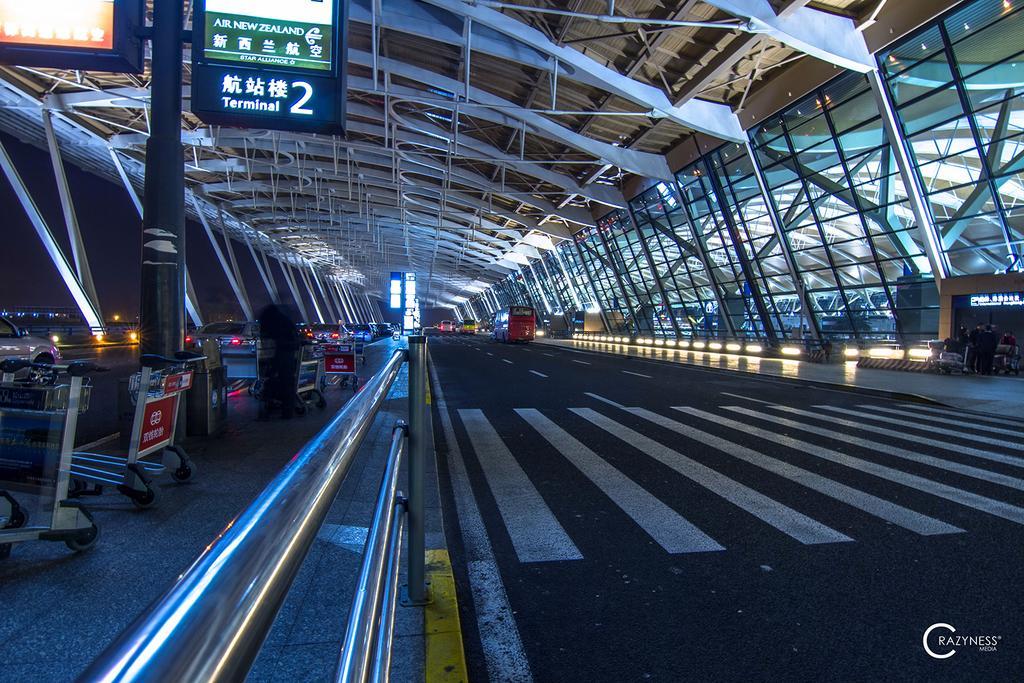In one or two sentences, can you explain what this image depicts? This image consists of a road. On the left, we can see handrail and trolleys. At the top, there is a roof made up of metal. It looks like an airport. 